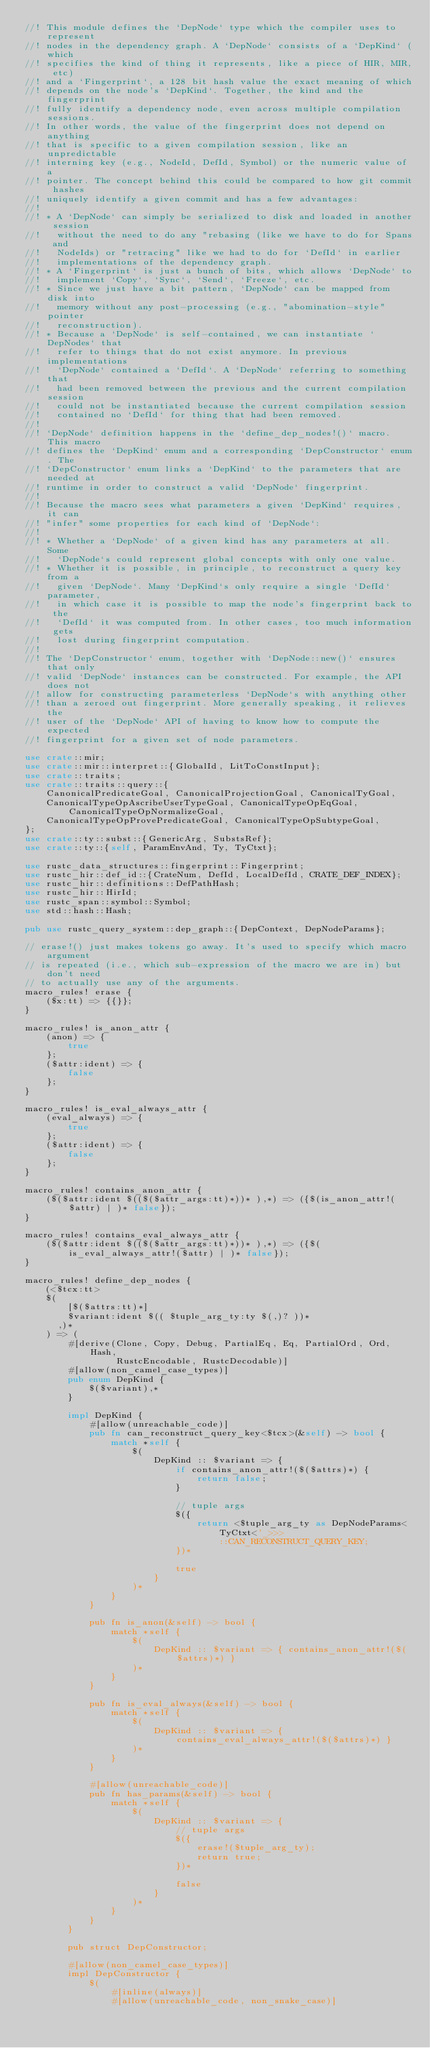<code> <loc_0><loc_0><loc_500><loc_500><_Rust_>//! This module defines the `DepNode` type which the compiler uses to represent
//! nodes in the dependency graph. A `DepNode` consists of a `DepKind` (which
//! specifies the kind of thing it represents, like a piece of HIR, MIR, etc)
//! and a `Fingerprint`, a 128 bit hash value the exact meaning of which
//! depends on the node's `DepKind`. Together, the kind and the fingerprint
//! fully identify a dependency node, even across multiple compilation sessions.
//! In other words, the value of the fingerprint does not depend on anything
//! that is specific to a given compilation session, like an unpredictable
//! interning key (e.g., NodeId, DefId, Symbol) or the numeric value of a
//! pointer. The concept behind this could be compared to how git commit hashes
//! uniquely identify a given commit and has a few advantages:
//!
//! * A `DepNode` can simply be serialized to disk and loaded in another session
//!   without the need to do any "rebasing (like we have to do for Spans and
//!   NodeIds) or "retracing" like we had to do for `DefId` in earlier
//!   implementations of the dependency graph.
//! * A `Fingerprint` is just a bunch of bits, which allows `DepNode` to
//!   implement `Copy`, `Sync`, `Send`, `Freeze`, etc.
//! * Since we just have a bit pattern, `DepNode` can be mapped from disk into
//!   memory without any post-processing (e.g., "abomination-style" pointer
//!   reconstruction).
//! * Because a `DepNode` is self-contained, we can instantiate `DepNodes` that
//!   refer to things that do not exist anymore. In previous implementations
//!   `DepNode` contained a `DefId`. A `DepNode` referring to something that
//!   had been removed between the previous and the current compilation session
//!   could not be instantiated because the current compilation session
//!   contained no `DefId` for thing that had been removed.
//!
//! `DepNode` definition happens in the `define_dep_nodes!()` macro. This macro
//! defines the `DepKind` enum and a corresponding `DepConstructor` enum. The
//! `DepConstructor` enum links a `DepKind` to the parameters that are needed at
//! runtime in order to construct a valid `DepNode` fingerprint.
//!
//! Because the macro sees what parameters a given `DepKind` requires, it can
//! "infer" some properties for each kind of `DepNode`:
//!
//! * Whether a `DepNode` of a given kind has any parameters at all. Some
//!   `DepNode`s could represent global concepts with only one value.
//! * Whether it is possible, in principle, to reconstruct a query key from a
//!   given `DepNode`. Many `DepKind`s only require a single `DefId` parameter,
//!   in which case it is possible to map the node's fingerprint back to the
//!   `DefId` it was computed from. In other cases, too much information gets
//!   lost during fingerprint computation.
//!
//! The `DepConstructor` enum, together with `DepNode::new()` ensures that only
//! valid `DepNode` instances can be constructed. For example, the API does not
//! allow for constructing parameterless `DepNode`s with anything other
//! than a zeroed out fingerprint. More generally speaking, it relieves the
//! user of the `DepNode` API of having to know how to compute the expected
//! fingerprint for a given set of node parameters.

use crate::mir;
use crate::mir::interpret::{GlobalId, LitToConstInput};
use crate::traits;
use crate::traits::query::{
    CanonicalPredicateGoal, CanonicalProjectionGoal, CanonicalTyGoal,
    CanonicalTypeOpAscribeUserTypeGoal, CanonicalTypeOpEqGoal, CanonicalTypeOpNormalizeGoal,
    CanonicalTypeOpProvePredicateGoal, CanonicalTypeOpSubtypeGoal,
};
use crate::ty::subst::{GenericArg, SubstsRef};
use crate::ty::{self, ParamEnvAnd, Ty, TyCtxt};

use rustc_data_structures::fingerprint::Fingerprint;
use rustc_hir::def_id::{CrateNum, DefId, LocalDefId, CRATE_DEF_INDEX};
use rustc_hir::definitions::DefPathHash;
use rustc_hir::HirId;
use rustc_span::symbol::Symbol;
use std::hash::Hash;

pub use rustc_query_system::dep_graph::{DepContext, DepNodeParams};

// erase!() just makes tokens go away. It's used to specify which macro argument
// is repeated (i.e., which sub-expression of the macro we are in) but don't need
// to actually use any of the arguments.
macro_rules! erase {
    ($x:tt) => {{}};
}

macro_rules! is_anon_attr {
    (anon) => {
        true
    };
    ($attr:ident) => {
        false
    };
}

macro_rules! is_eval_always_attr {
    (eval_always) => {
        true
    };
    ($attr:ident) => {
        false
    };
}

macro_rules! contains_anon_attr {
    ($($attr:ident $(($($attr_args:tt)*))* ),*) => ({$(is_anon_attr!($attr) | )* false});
}

macro_rules! contains_eval_always_attr {
    ($($attr:ident $(($($attr_args:tt)*))* ),*) => ({$(is_eval_always_attr!($attr) | )* false});
}

macro_rules! define_dep_nodes {
    (<$tcx:tt>
    $(
        [$($attrs:tt)*]
        $variant:ident $(( $tuple_arg_ty:ty $(,)? ))*
      ,)*
    ) => (
        #[derive(Clone, Copy, Debug, PartialEq, Eq, PartialOrd, Ord, Hash,
                 RustcEncodable, RustcDecodable)]
        #[allow(non_camel_case_types)]
        pub enum DepKind {
            $($variant),*
        }

        impl DepKind {
            #[allow(unreachable_code)]
            pub fn can_reconstruct_query_key<$tcx>(&self) -> bool {
                match *self {
                    $(
                        DepKind :: $variant => {
                            if contains_anon_attr!($($attrs)*) {
                                return false;
                            }

                            // tuple args
                            $({
                                return <$tuple_arg_ty as DepNodeParams<TyCtxt<'_>>>
                                    ::CAN_RECONSTRUCT_QUERY_KEY;
                            })*

                            true
                        }
                    )*
                }
            }

            pub fn is_anon(&self) -> bool {
                match *self {
                    $(
                        DepKind :: $variant => { contains_anon_attr!($($attrs)*) }
                    )*
                }
            }

            pub fn is_eval_always(&self) -> bool {
                match *self {
                    $(
                        DepKind :: $variant => { contains_eval_always_attr!($($attrs)*) }
                    )*
                }
            }

            #[allow(unreachable_code)]
            pub fn has_params(&self) -> bool {
                match *self {
                    $(
                        DepKind :: $variant => {
                            // tuple args
                            $({
                                erase!($tuple_arg_ty);
                                return true;
                            })*

                            false
                        }
                    )*
                }
            }
        }

        pub struct DepConstructor;

        #[allow(non_camel_case_types)]
        impl DepConstructor {
            $(
                #[inline(always)]
                #[allow(unreachable_code, non_snake_case)]</code> 